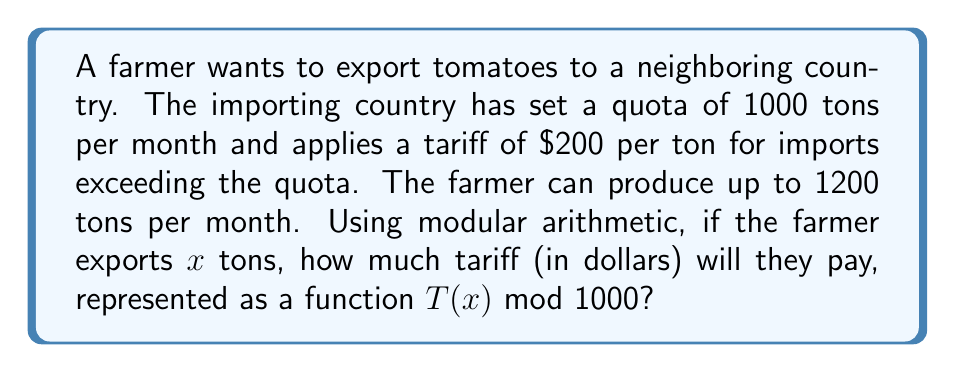Teach me how to tackle this problem. Let's approach this step-by-step:

1) First, we need to understand that the tariff only applies to the amount exceeding the quota. So, we're interested in $\max(0, x - 1000)$.

2) The tariff function can be written as:

   $$T(x) = 200 \cdot \max(0, x - 1000)$$

3) Now, let's consider this function modulo 1000. We can break it down into cases:

   Case 1: When $x \leq 1000$
   $$T(x) \equiv 0 \pmod{1000}$$

   Case 2: When $x > 1000$
   $$T(x) \equiv 200(x - 1000) \pmod{1000}$$

4) For Case 2, we can simplify:
   $$200(x - 1000) \equiv 200x - 200000 \equiv 200x + 800 \pmod{1000}$$

5) Therefore, we can write the complete function as:

   $$T(x) \equiv \begin{cases} 
   0 & \text{if } x \leq 1000 \\
   200x + 800 & \text{if } x > 1000
   \end{cases} \pmod{1000}$$

6) Note that $200x + 800 \equiv 200(x \bmod 5) + 800 \pmod{1000}$, because $200 \cdot 5 \equiv 0 \pmod{1000}$.

This means the function repeats every 5 tons above 1000 tons.
Answer: $$T(x) \equiv \begin{cases} 
0 & \text{if } x \leq 1000 \\
200(x \bmod 5) + 800 & \text{if } x > 1000
\end{cases} \pmod{1000}$$ 